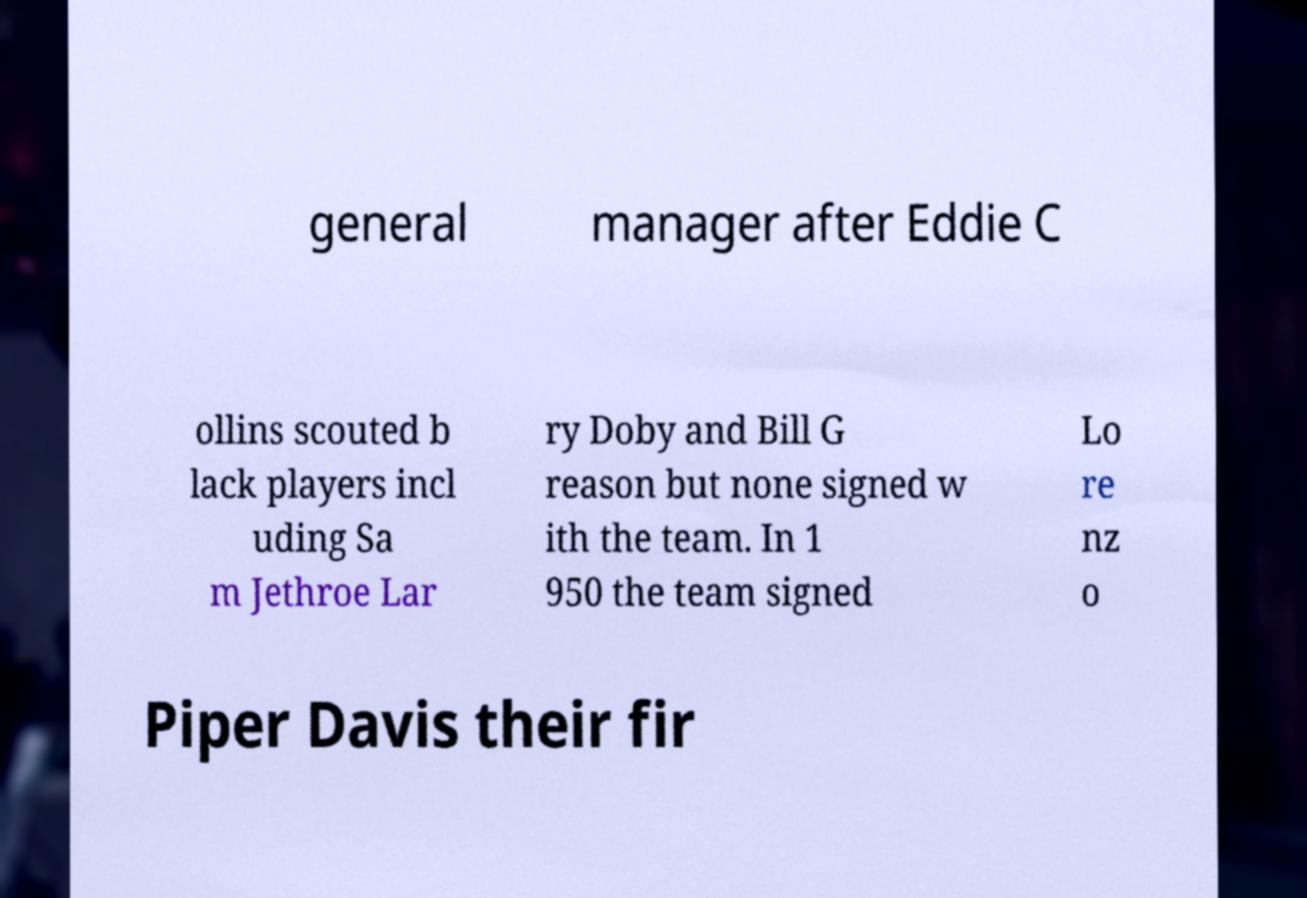Please identify and transcribe the text found in this image. general manager after Eddie C ollins scouted b lack players incl uding Sa m Jethroe Lar ry Doby and Bill G reason but none signed w ith the team. In 1 950 the team signed Lo re nz o Piper Davis their fir 